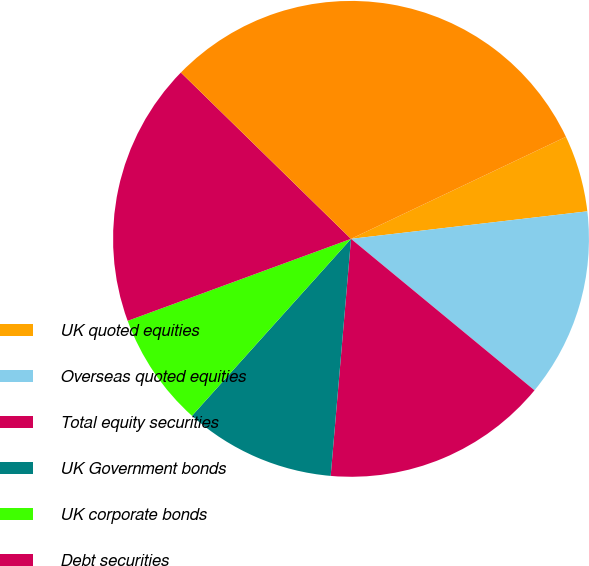Convert chart to OTSL. <chart><loc_0><loc_0><loc_500><loc_500><pie_chart><fcel>UK quoted equities<fcel>Overseas quoted equities<fcel>Total equity securities<fcel>UK Government bonds<fcel>UK corporate bonds<fcel>Debt securities<fcel>Total<nl><fcel>5.21%<fcel>12.83%<fcel>15.38%<fcel>10.29%<fcel>7.75%<fcel>17.92%<fcel>30.63%<nl></chart> 